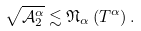Convert formula to latex. <formula><loc_0><loc_0><loc_500><loc_500>\sqrt { \mathcal { A } _ { 2 } ^ { \alpha } } \lesssim \mathfrak { N } _ { \alpha } \left ( T ^ { \alpha } \right ) .</formula> 